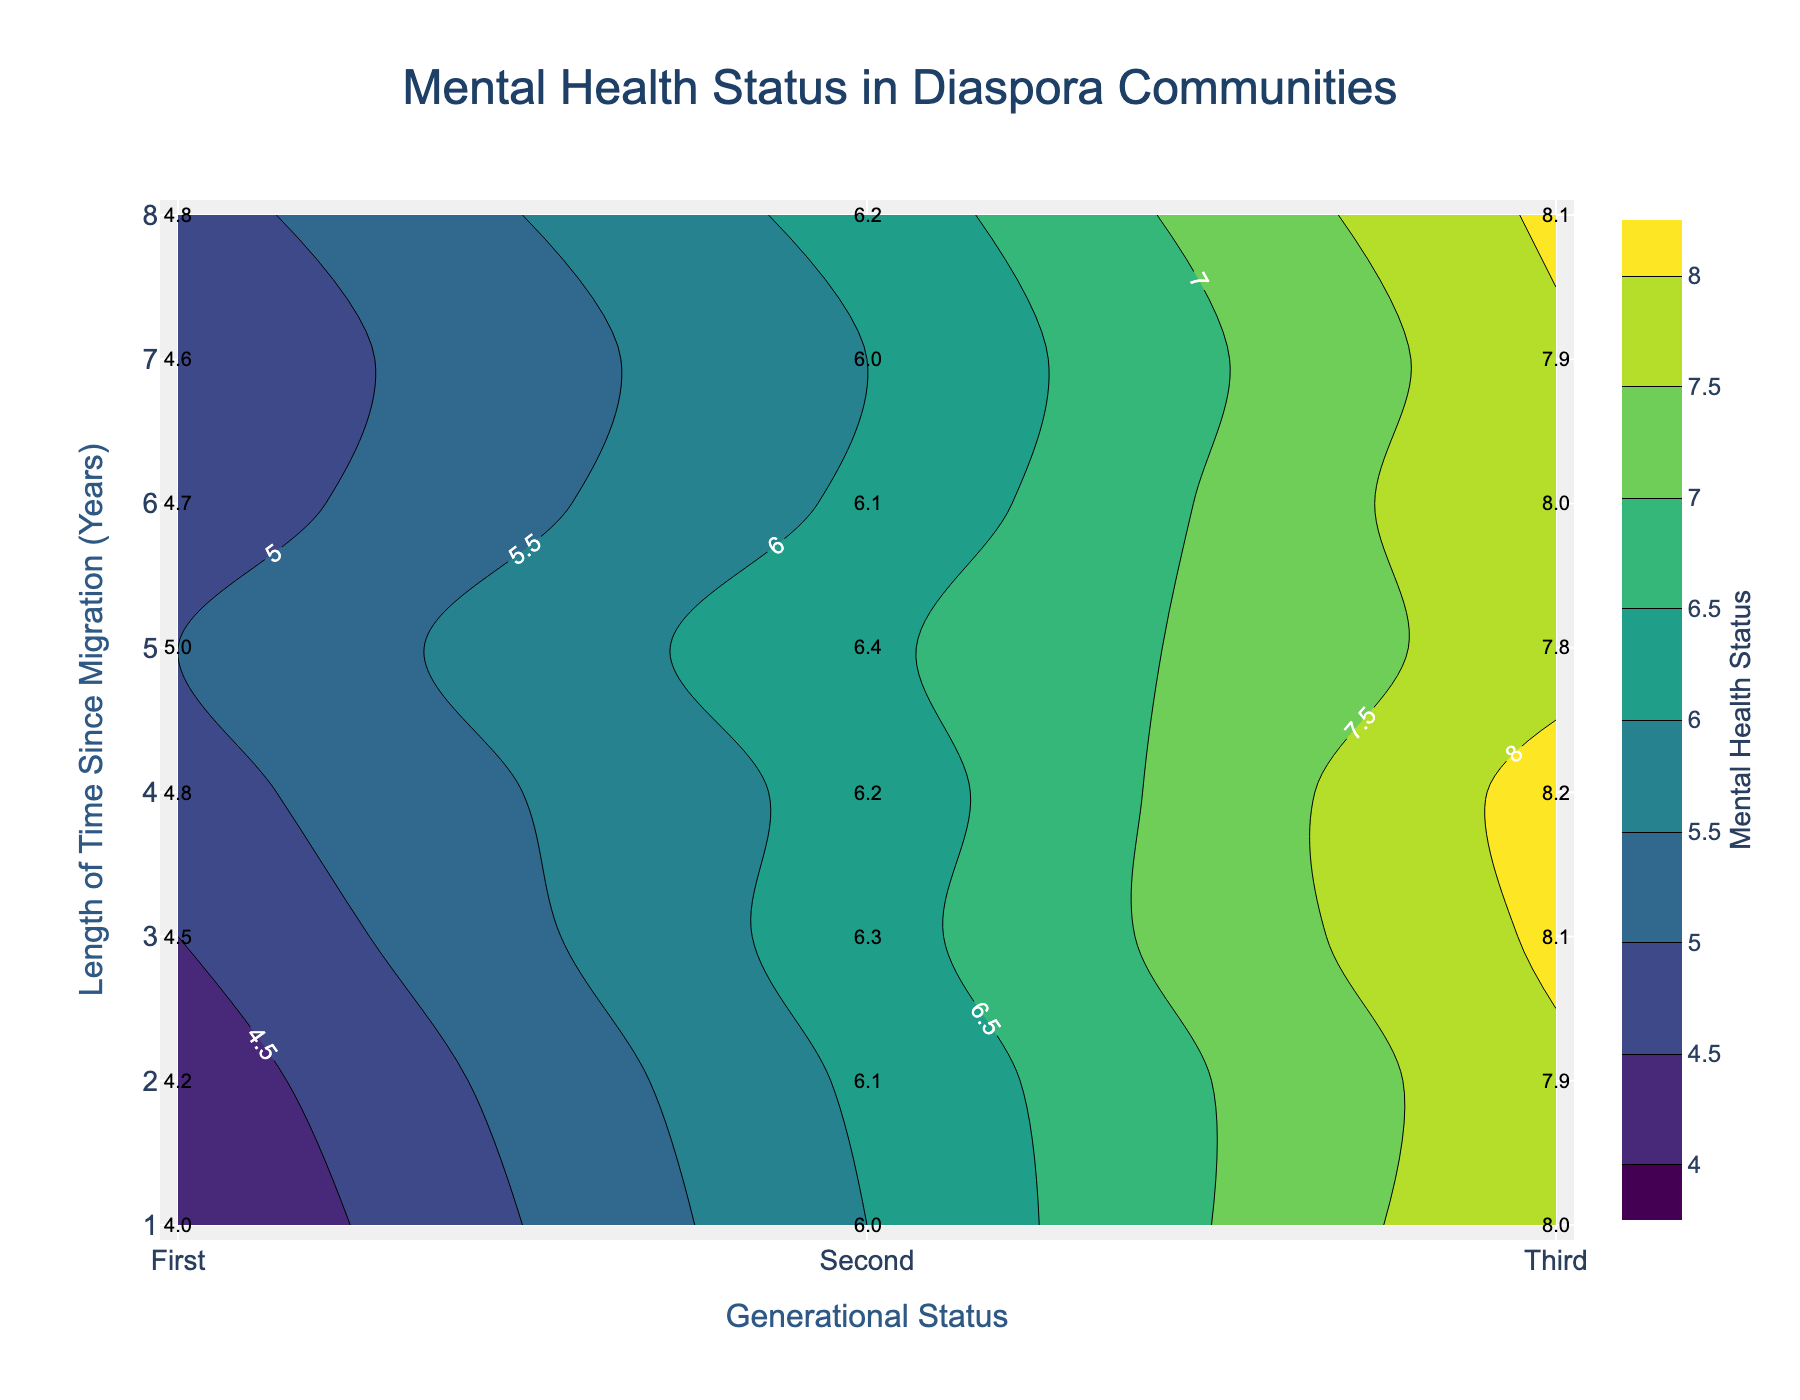What is the title of the plot? The title of the plot is located at the top center of the figure. It is "Mental Health Status in Diaspora Communities."
Answer: Mental Health Status in Diaspora Communities What does the colorbar on the right side of the plot represent? The colorbar on the right side of the plot shows the "Mental Health Status." It provides a scale from 4 to 8, indicating the values represented by different colors.
Answer: Mental Health Status What generational status has the highest mental health status for the longest time since migration? By looking at the labels and contours, the "Third" generational status shows the highest mental health status for a length of 8 years since migration.
Answer: Third How does the mental health status of the first generation change as the length of time since migration increases? Observing the contour lines and labels, the mental health status of the first generation generally increases from 4.0 to 5.0 and then slightly decreases, remaining around 4.8 as the length of time increases.
Answer: Generally increases, then slightly decreases Which generational status remains the most stable in terms of mental health over different time periods? By comparing the contour lines' steepness and the labels, the "Third" generational status remains the most stable with mental health status values consistently around 8.0 to 8.2.
Answer: Third Calculate the average mental health status for the second generation over the period of 4 to 6 years since migration. First, identify the mental health status from the labels for the specific period: 6.2, 6.4, and 6.1. Sum these values: 6.2 + 6.4 + 6.1 = 18.7. Then, divide by the number of years (3). 18.7 / 3 = 6.23
Answer: 6.23 Which length of time since migration corresponds to the highest mental health status for the first generation? Looking at the labels, the highest mental health status for the first generation is 5.0 at 5 years since migration.
Answer: 5 years How does the contour density differ between the first and third generations? The contour lines for the first generation are more closely packed, indicating a quicker change in mental health status over time, whereas the third generation's contour lines are spread wider, indicating more stability.
Answer: More closely packed for the first generation; wider for the third generation What is the mental health status for the second generation at 3 years since migration? Refer to the label on the contour plot for the second generation at 3 years, which shows a mental health status value of 6.3.
Answer: 6.3 Is there any observable pattern in mental health status improvement or decline across generational statuses? By observing the contours, mental health status generally improves as the generational status progresses from first to third generation.
Answer: Generally improves across generations 